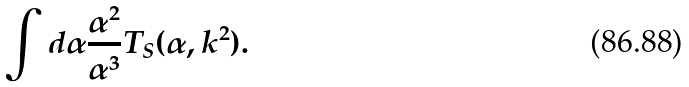<formula> <loc_0><loc_0><loc_500><loc_500>\int d \alpha \frac { \alpha ^ { 2 } } { \alpha ^ { 3 } } T _ { S } ( \alpha , k ^ { 2 } ) .</formula> 